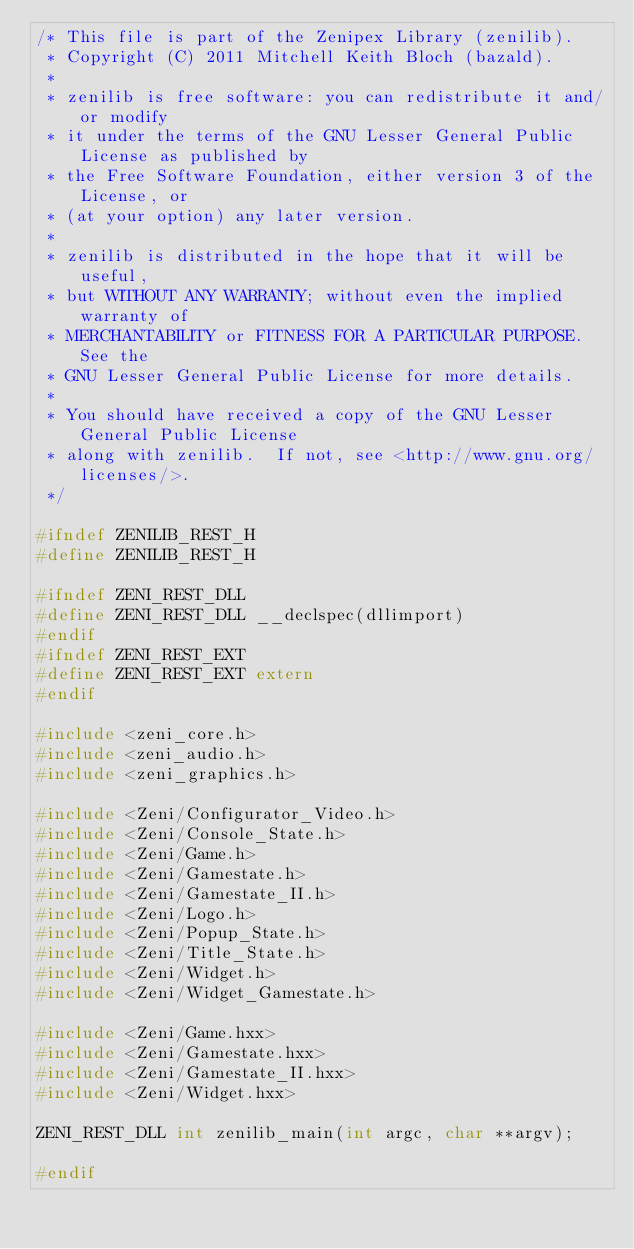Convert code to text. <code><loc_0><loc_0><loc_500><loc_500><_C_>/* This file is part of the Zenipex Library (zenilib).
 * Copyright (C) 2011 Mitchell Keith Bloch (bazald).
 *
 * zenilib is free software: you can redistribute it and/or modify
 * it under the terms of the GNU Lesser General Public License as published by
 * the Free Software Foundation, either version 3 of the License, or
 * (at your option) any later version.
 *
 * zenilib is distributed in the hope that it will be useful,
 * but WITHOUT ANY WARRANTY; without even the implied warranty of
 * MERCHANTABILITY or FITNESS FOR A PARTICULAR PURPOSE.  See the
 * GNU Lesser General Public License for more details.
 *
 * You should have received a copy of the GNU Lesser General Public License
 * along with zenilib.  If not, see <http://www.gnu.org/licenses/>.
 */

#ifndef ZENILIB_REST_H
#define ZENILIB_REST_H

#ifndef ZENI_REST_DLL
#define ZENI_REST_DLL __declspec(dllimport)
#endif
#ifndef ZENI_REST_EXT
#define ZENI_REST_EXT extern
#endif

#include <zeni_core.h>
#include <zeni_audio.h>
#include <zeni_graphics.h>

#include <Zeni/Configurator_Video.h>
#include <Zeni/Console_State.h>
#include <Zeni/Game.h>
#include <Zeni/Gamestate.h>
#include <Zeni/Gamestate_II.h>
#include <Zeni/Logo.h>
#include <Zeni/Popup_State.h>
#include <Zeni/Title_State.h>
#include <Zeni/Widget.h>
#include <Zeni/Widget_Gamestate.h>

#include <Zeni/Game.hxx>
#include <Zeni/Gamestate.hxx>
#include <Zeni/Gamestate_II.hxx>
#include <Zeni/Widget.hxx>

ZENI_REST_DLL int zenilib_main(int argc, char **argv);

#endif
</code> 